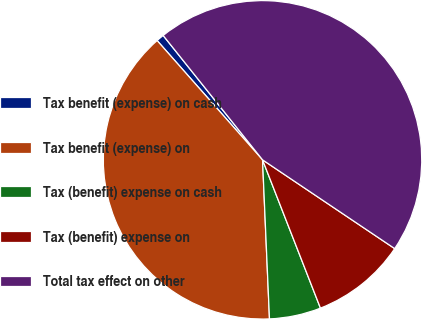Convert chart. <chart><loc_0><loc_0><loc_500><loc_500><pie_chart><fcel>Tax benefit (expense) on cash<fcel>Tax benefit (expense) on<fcel>Tax (benefit) expense on cash<fcel>Tax (benefit) expense on<fcel>Total tax effect on other<nl><fcel>0.79%<fcel>39.17%<fcel>5.23%<fcel>9.66%<fcel>45.14%<nl></chart> 